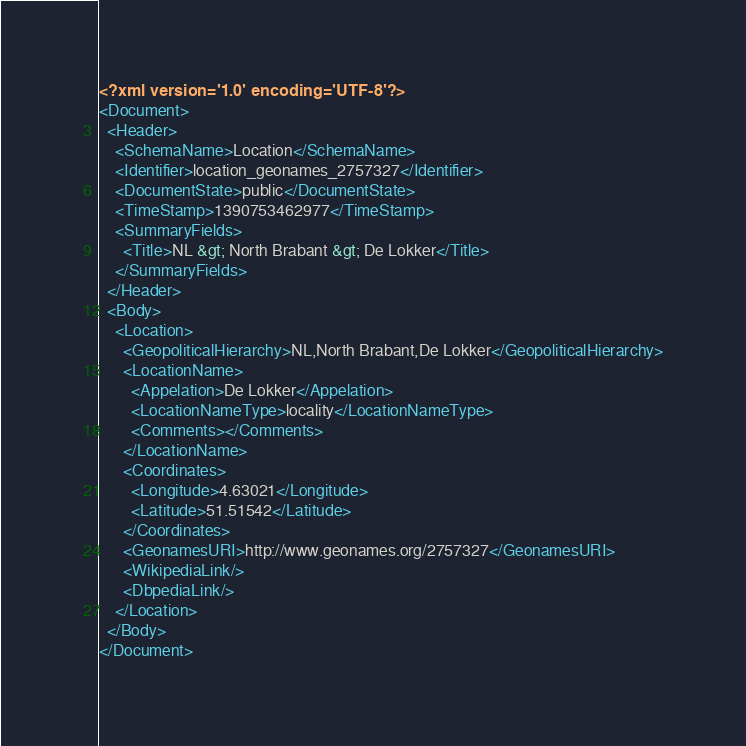Convert code to text. <code><loc_0><loc_0><loc_500><loc_500><_XML_><?xml version='1.0' encoding='UTF-8'?>
<Document>
  <Header>
    <SchemaName>Location</SchemaName>
    <Identifier>location_geonames_2757327</Identifier>
    <DocumentState>public</DocumentState>
    <TimeStamp>1390753462977</TimeStamp>
    <SummaryFields>
      <Title>NL &gt; North Brabant &gt; De Lokker</Title>
    </SummaryFields>
  </Header>
  <Body>
    <Location>
      <GeopoliticalHierarchy>NL,North Brabant,De Lokker</GeopoliticalHierarchy>
      <LocationName>
        <Appelation>De Lokker</Appelation>
        <LocationNameType>locality</LocationNameType>
        <Comments></Comments>
      </LocationName>
      <Coordinates>
        <Longitude>4.63021</Longitude>
        <Latitude>51.51542</Latitude>
      </Coordinates>
      <GeonamesURI>http://www.geonames.org/2757327</GeonamesURI>
      <WikipediaLink/>
      <DbpediaLink/>
    </Location>
  </Body>
</Document>
</code> 